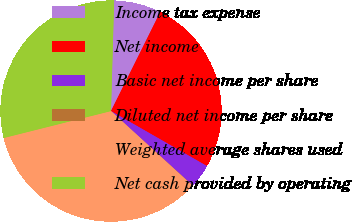<chart> <loc_0><loc_0><loc_500><loc_500><pie_chart><fcel>Income tax expense<fcel>Net income<fcel>Basic net income per share<fcel>Diluted net income per share<fcel>Weighted average shares used<fcel>Net cash provided by operating<nl><fcel>6.89%<fcel>25.94%<fcel>3.47%<fcel>0.04%<fcel>34.29%<fcel>29.37%<nl></chart> 